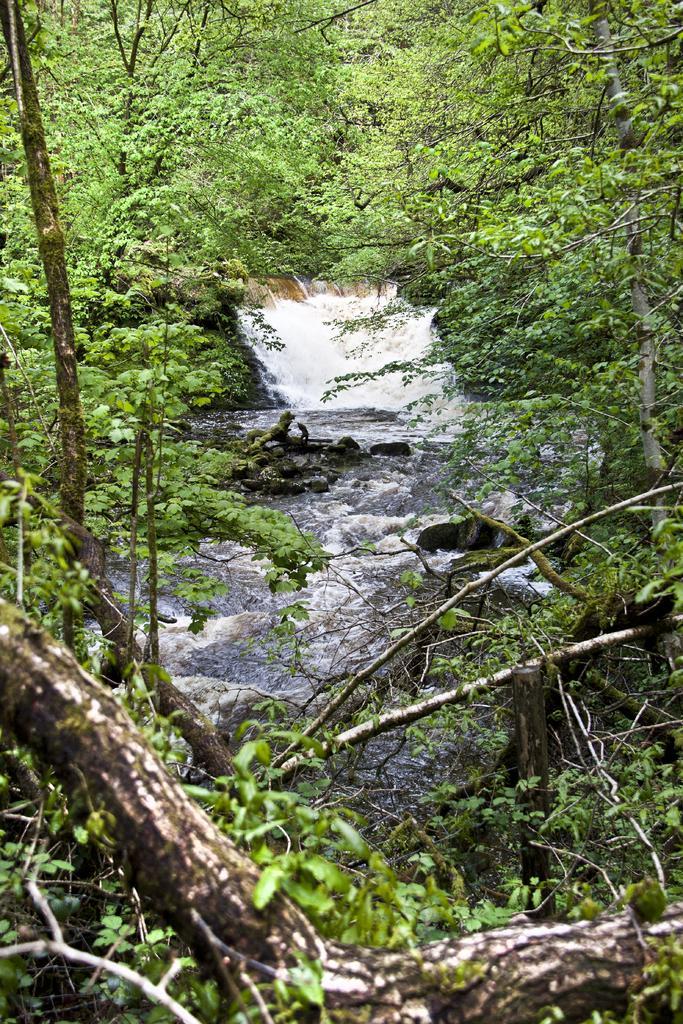Can you describe this image briefly? In this picture we can see water, few rocks and trees. 